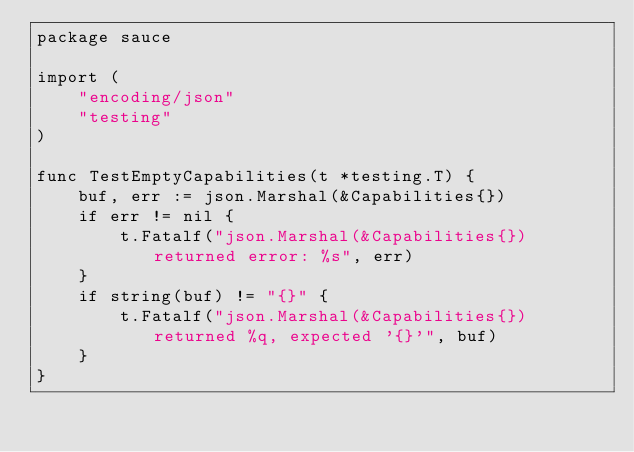<code> <loc_0><loc_0><loc_500><loc_500><_Go_>package sauce

import (
	"encoding/json"
	"testing"
)

func TestEmptyCapabilities(t *testing.T) {
	buf, err := json.Marshal(&Capabilities{})
	if err != nil {
		t.Fatalf("json.Marshal(&Capabilities{}) returned error: %s", err)
	}
	if string(buf) != "{}" {
		t.Fatalf("json.Marshal(&Capabilities{}) returned %q, expected '{}'", buf)
	}
}
</code> 